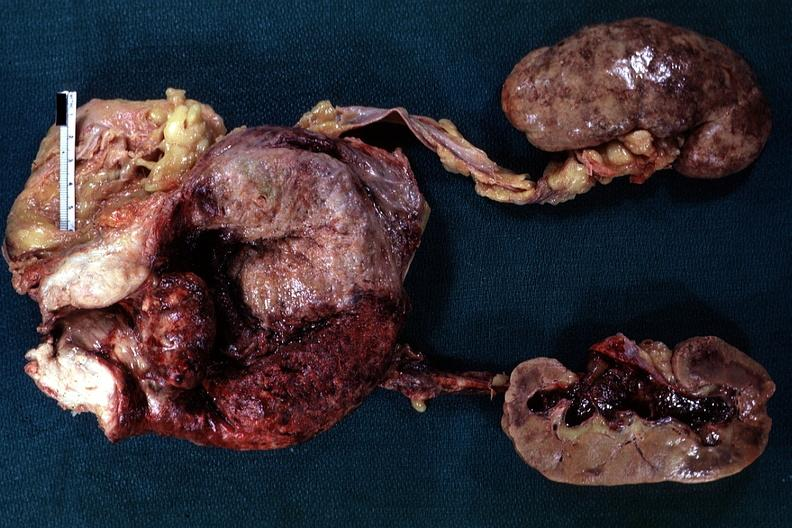what is present?
Answer the question using a single word or phrase. Hyperplasia median bar 